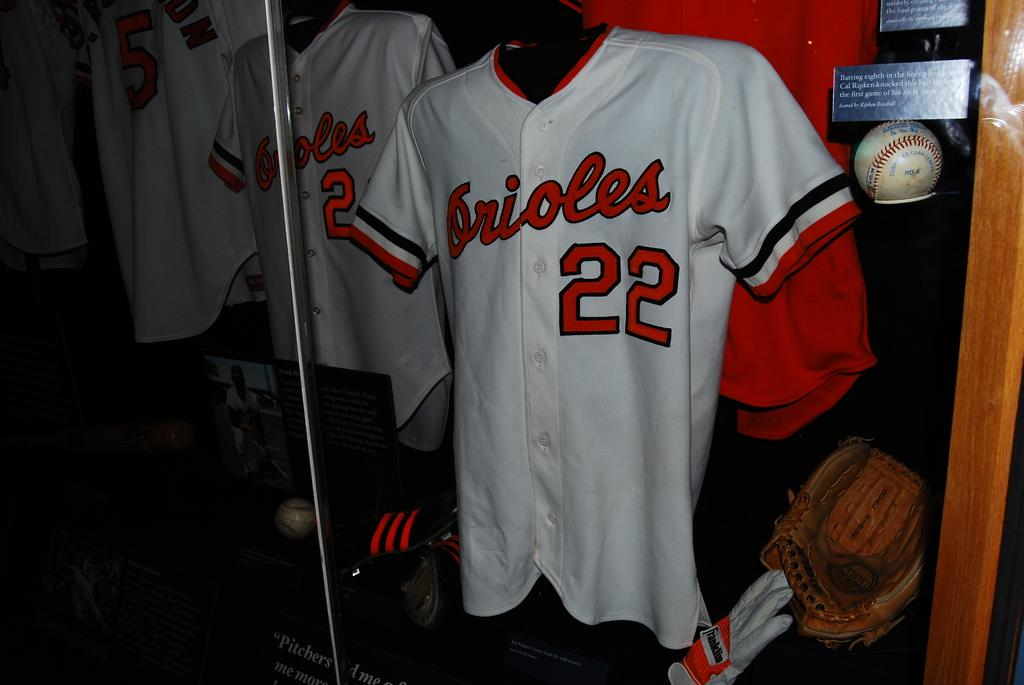<image>
Summarize the visual content of the image. A jersey in a display case that is Orioles number 22 next to a ball and mitt. 